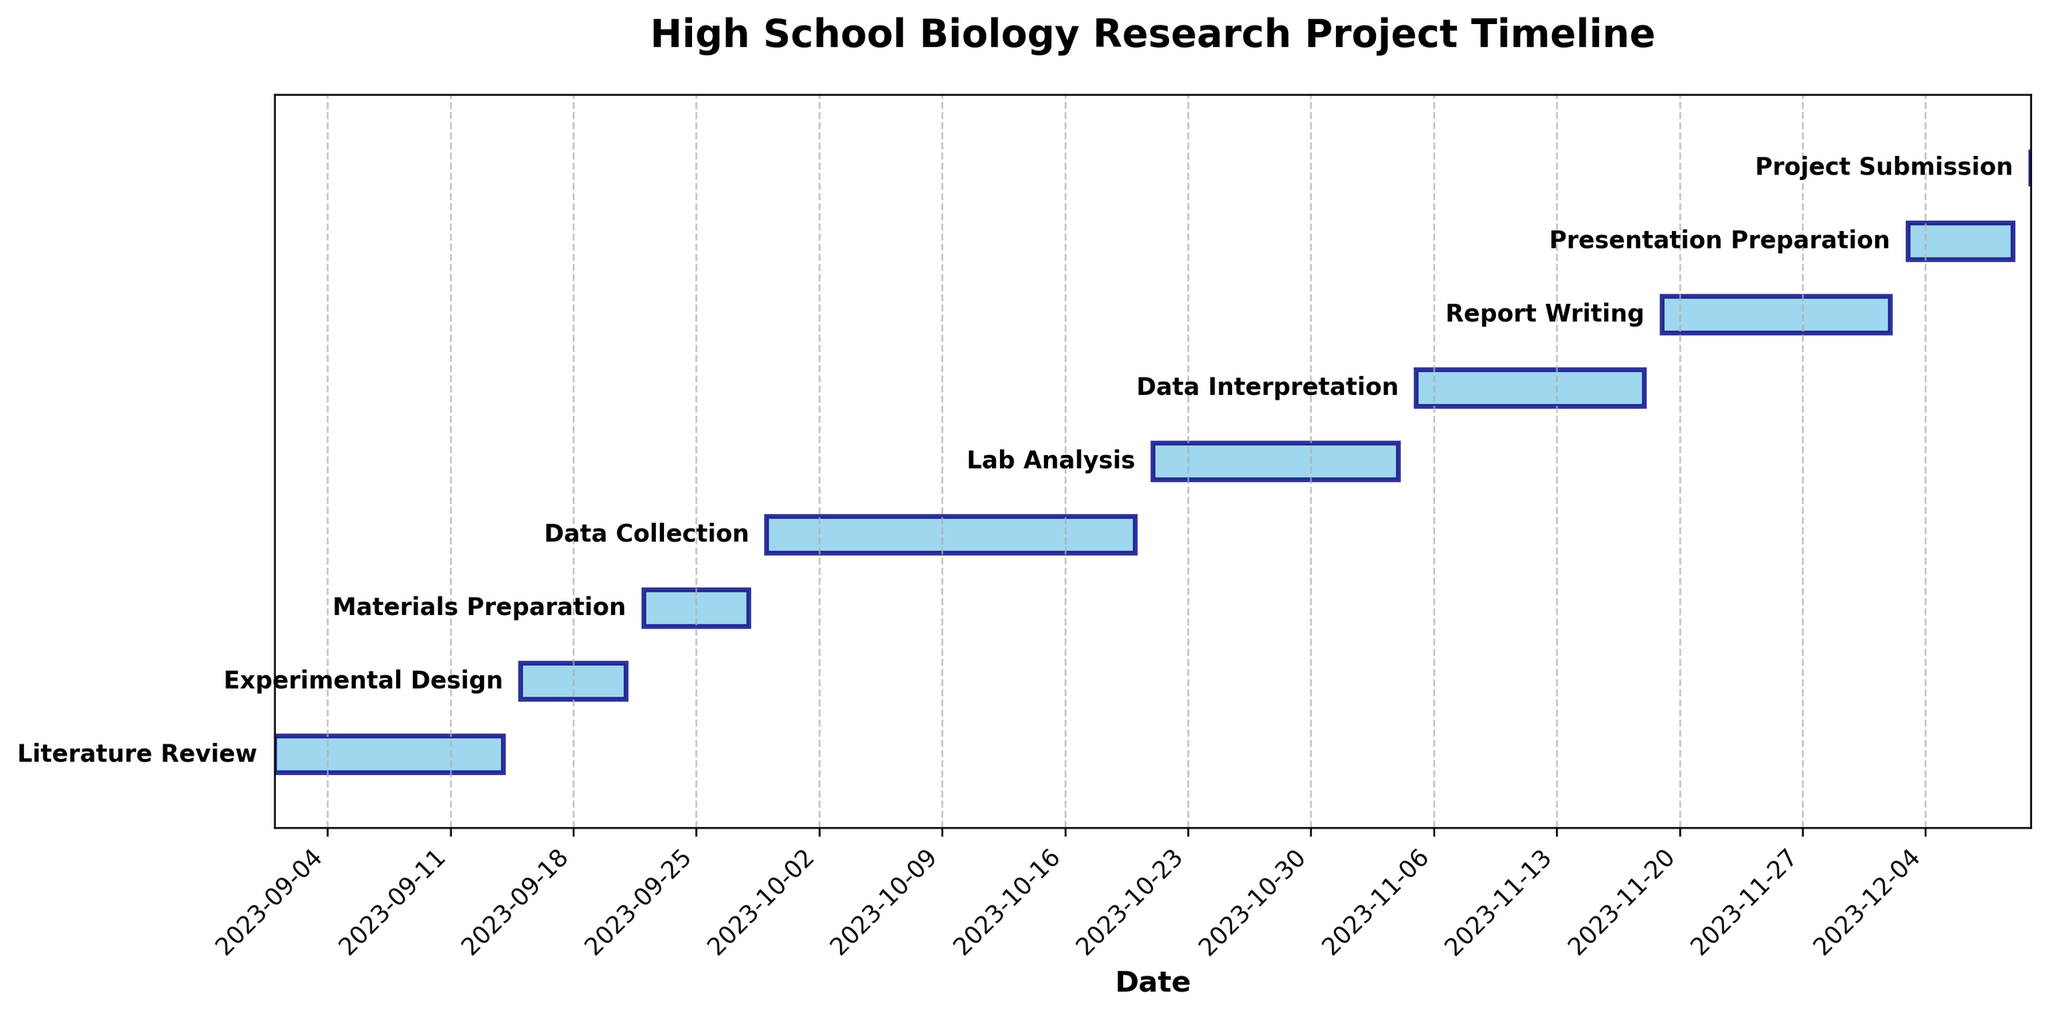What is the title of the chart? The title of the chart is found at the top of the figure. It is written in a bold font to distinguish it as the main header.
Answer: High School Biology Research Project Timeline How many total tasks are displayed in the Gantt chart? Count the number of horizontal bars, each representing a different task.
Answer: 9 What task has the longest duration? Find the horizontal bar that spans the longest distance on the x-axis. The length corresponds to the duration of the task.
Answer: Data Collection What is the total duration for Literature Review and Experimental Design combined? Find the durations of Literature Review and Experimental Design and add them together. Literature Review is 14 days, and Experimental Design is 7 days. 14 + 7 = 21 days
Answer: 21 days Which task finishes closest to November 1, 2023? Examine the end dates of tasks near November 1, 2023. Lab Analysis ends on November 4, 2023.
Answer: Lab Analysis What is the duration difference between Report Writing and Presentation Preparation? Subtract the duration of Presentation Preparation from the duration of Report Writing. Report Writing is 14 days, and Presentation Preparation is 7 days. 14 - 7 = 7 days
Answer: 7 days Which task starts immediately after Experimental Design? Look at the end date of Experimental Design and find the task that starts the next day. Experimental Design ends on September 21, 2023, and Materials Preparation starts on September 22, 2023.
Answer: Materials Preparation What is the average duration of all tasks? Sum the durations of all tasks and divide by the number of tasks. (14 + 7 + 7 + 22 + 15 + 14 + 14 + 7 + 1) / 9 = 10.1 days
Answer: 10.1 days Which task ends last in the timeline? Identify the task with the latest end date. Project Submission ends on December 10, 2023.
Answer: Project Submission 